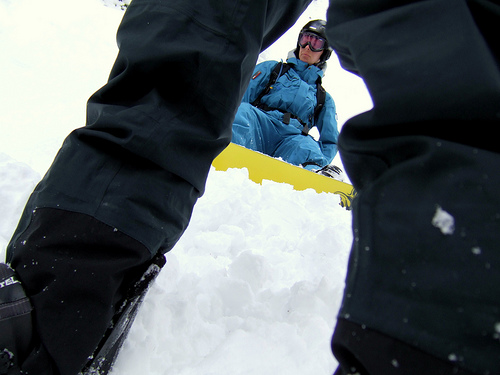<image>
Is there a snow in front of the man? Yes. The snow is positioned in front of the man, appearing closer to the camera viewpoint. 